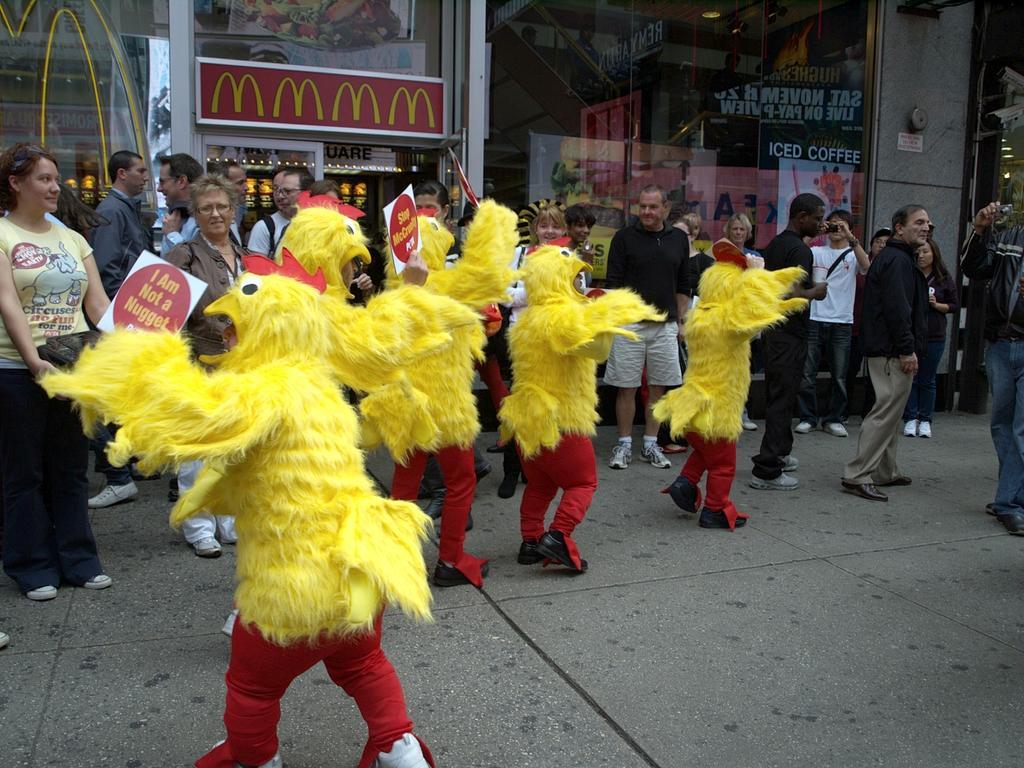Can you describe this image briefly? In this picture, we can see a group of people standing and some people are in the fancy dresses. Behind the people, there is a building with glass doors. Inside the building, there are posters, light and some objects. 